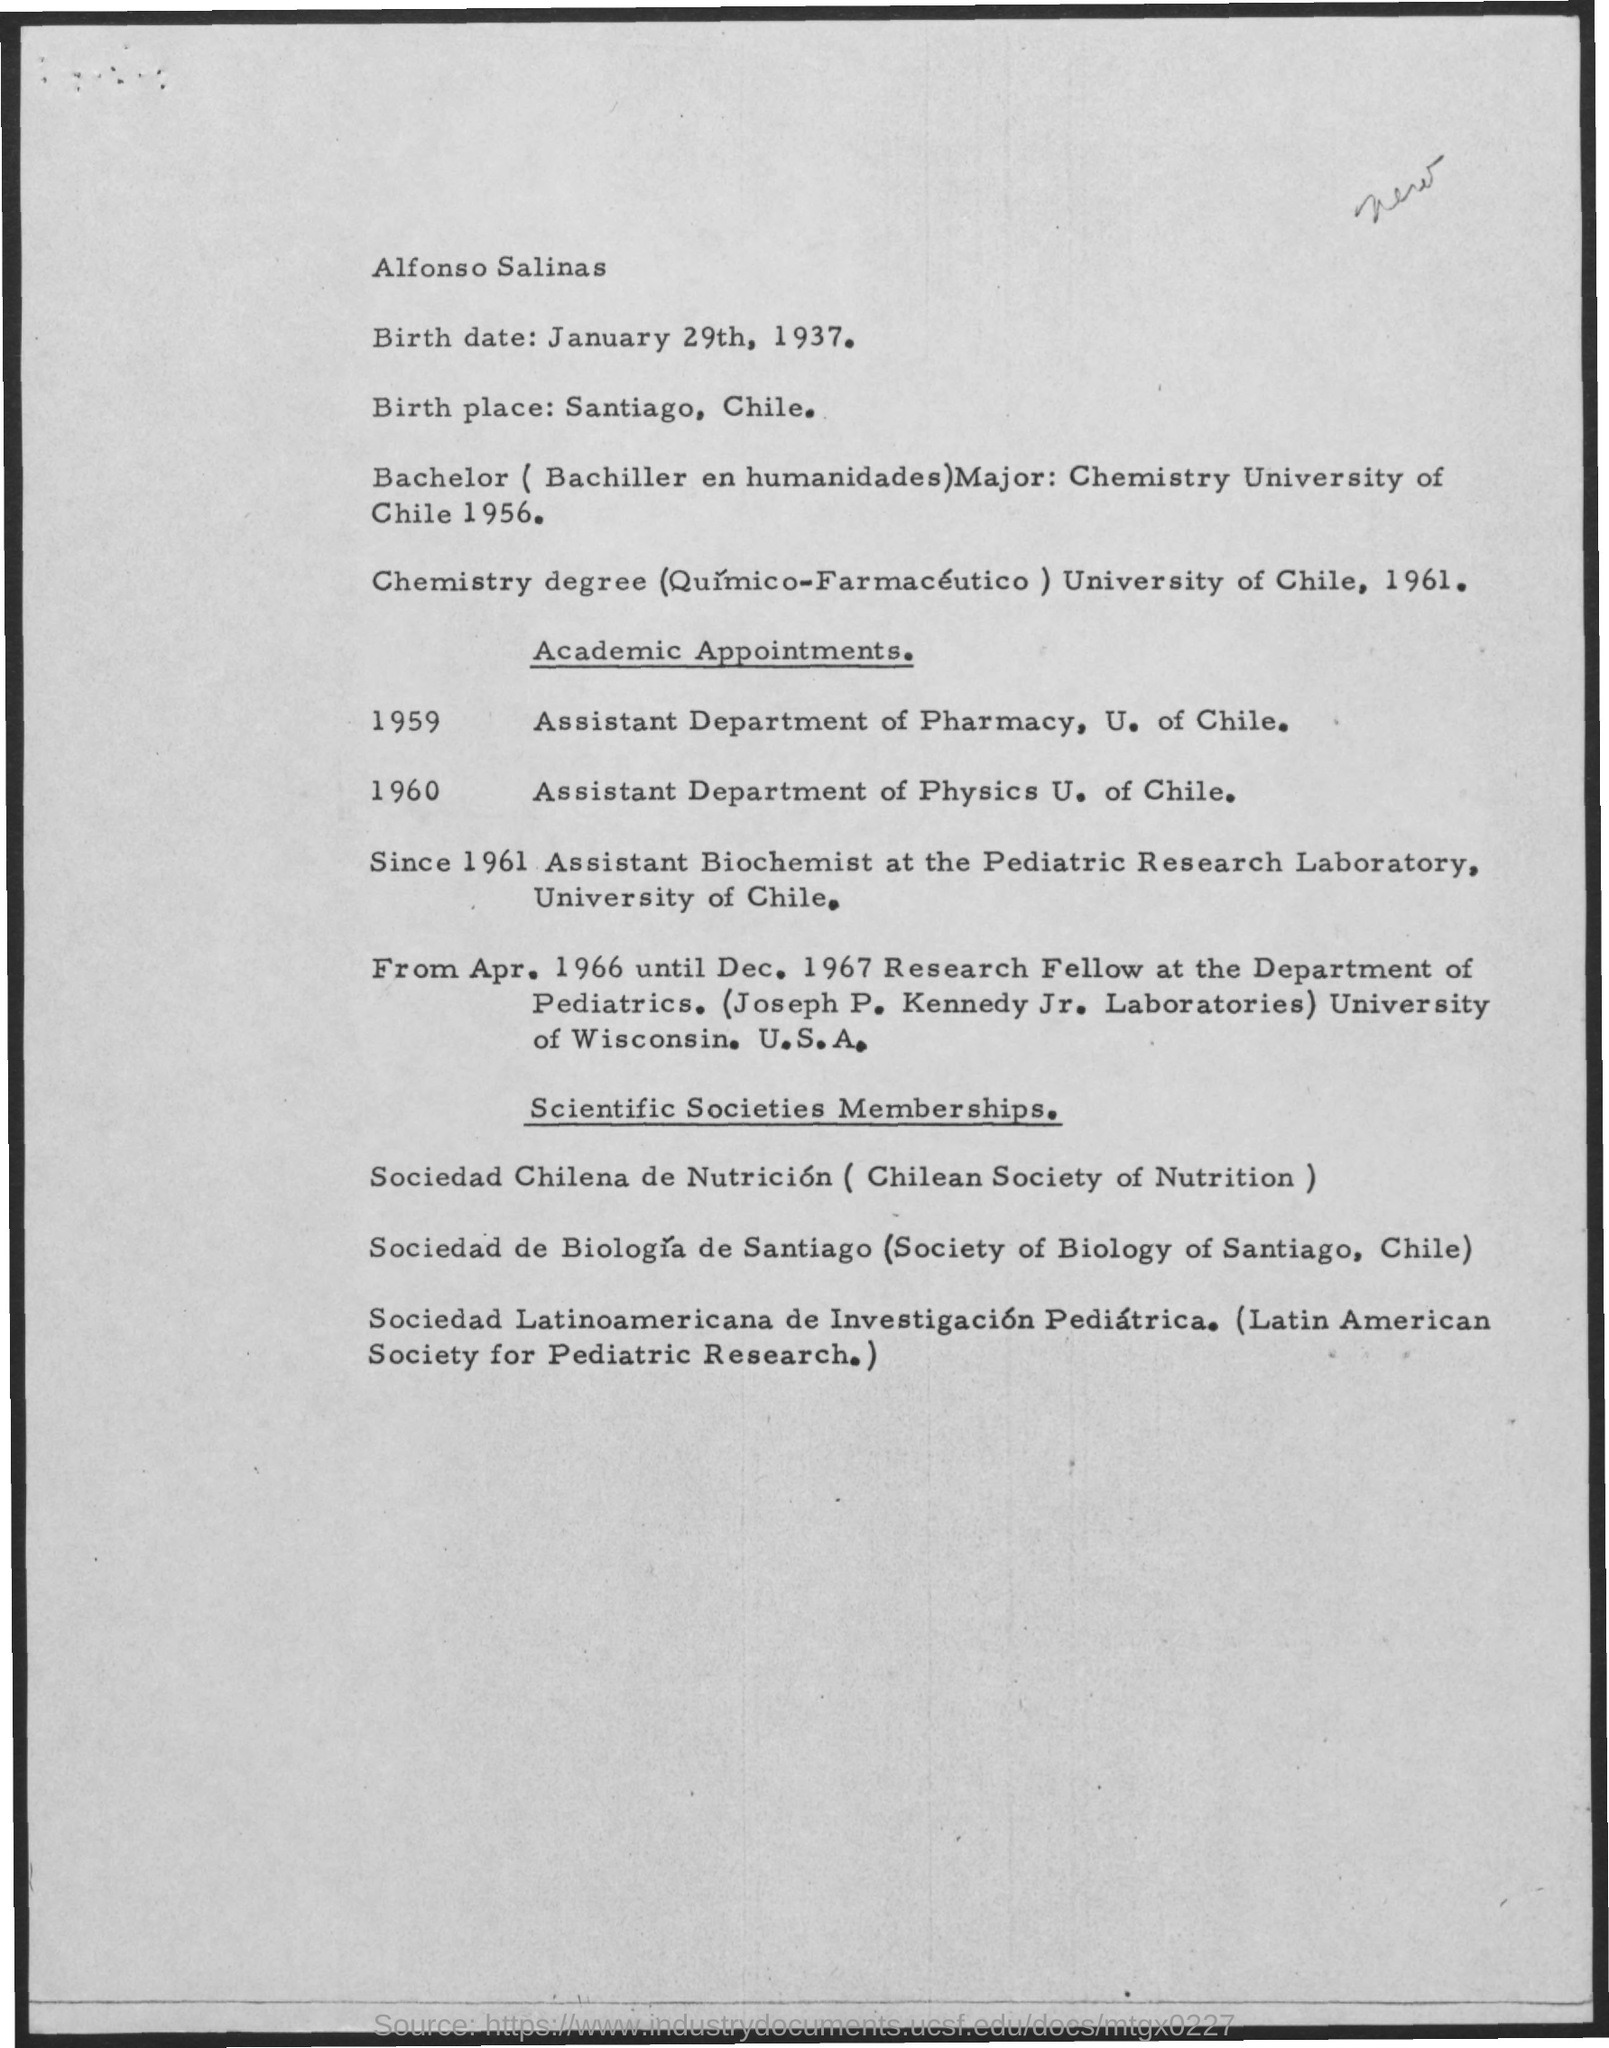Mention a couple of crucial points in this snapshot. Santiago, Chile is the birthplace of Alfonso Salinas. On January 29th, 1937, Alfonso Salinas was born. 